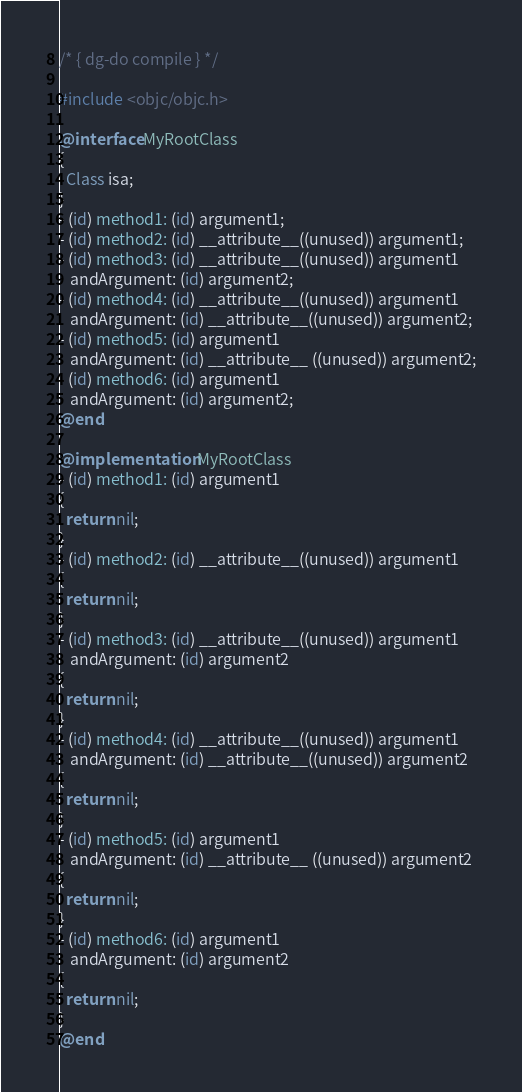Convert code to text. <code><loc_0><loc_0><loc_500><loc_500><_ObjectiveC_>/* { dg-do compile } */

#include <objc/objc.h>

@interface MyRootClass
{
  Class isa;
}
- (id) method1: (id) argument1;
- (id) method2: (id) __attribute__((unused)) argument1;
- (id) method3: (id) __attribute__((unused)) argument1
   andArgument: (id) argument2;
- (id) method4: (id) __attribute__((unused)) argument1
   andArgument: (id) __attribute__((unused)) argument2;
- (id) method5: (id) argument1
   andArgument: (id) __attribute__ ((unused)) argument2;
- (id) method6: (id) argument1
   andArgument: (id) argument2;
@end

@implementation MyRootClass
- (id) method1: (id) argument1
{
  return nil;
}
- (id) method2: (id) __attribute__((unused)) argument1
{
  return nil;
}
- (id) method3: (id) __attribute__((unused)) argument1
   andArgument: (id) argument2
{
  return nil;
}
- (id) method4: (id) __attribute__((unused)) argument1
   andArgument: (id) __attribute__((unused)) argument2
{
  return nil;
}
- (id) method5: (id) argument1
   andArgument: (id) __attribute__ ((unused)) argument2
{
  return nil;
}
- (id) method6: (id) argument1
   andArgument: (id) argument2
{
  return nil;
}
@end
</code> 